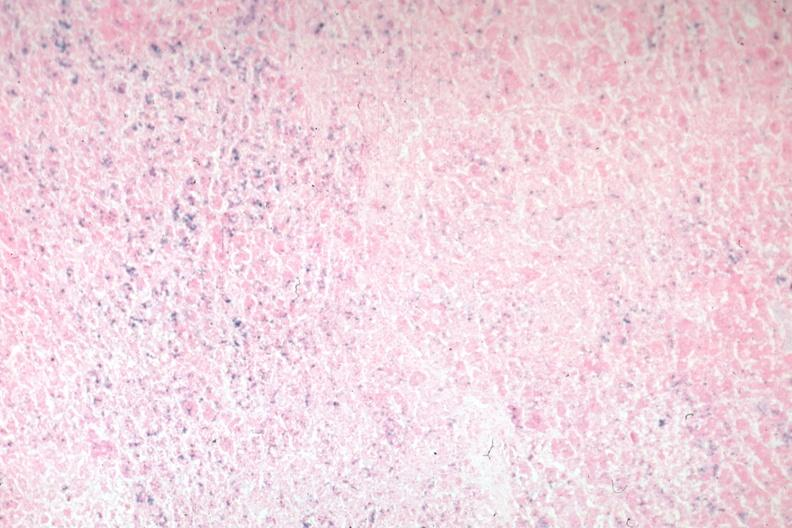what is present?
Answer the question using a single word or phrase. Pituitary 